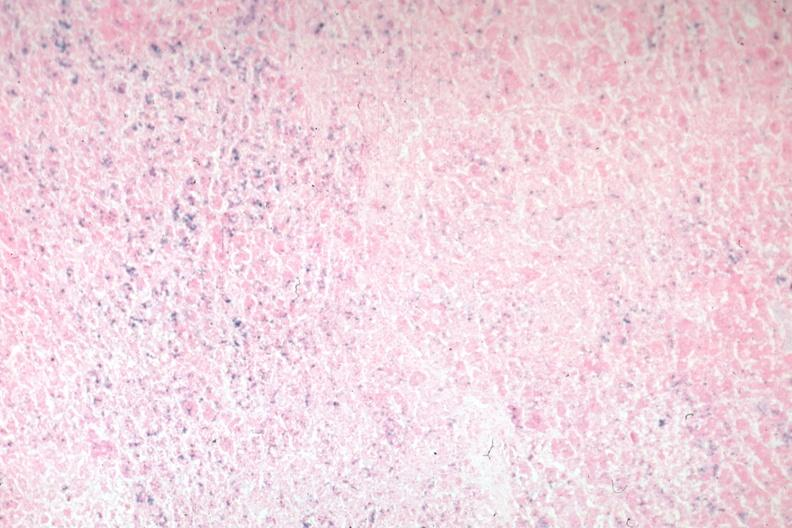what is present?
Answer the question using a single word or phrase. Pituitary 